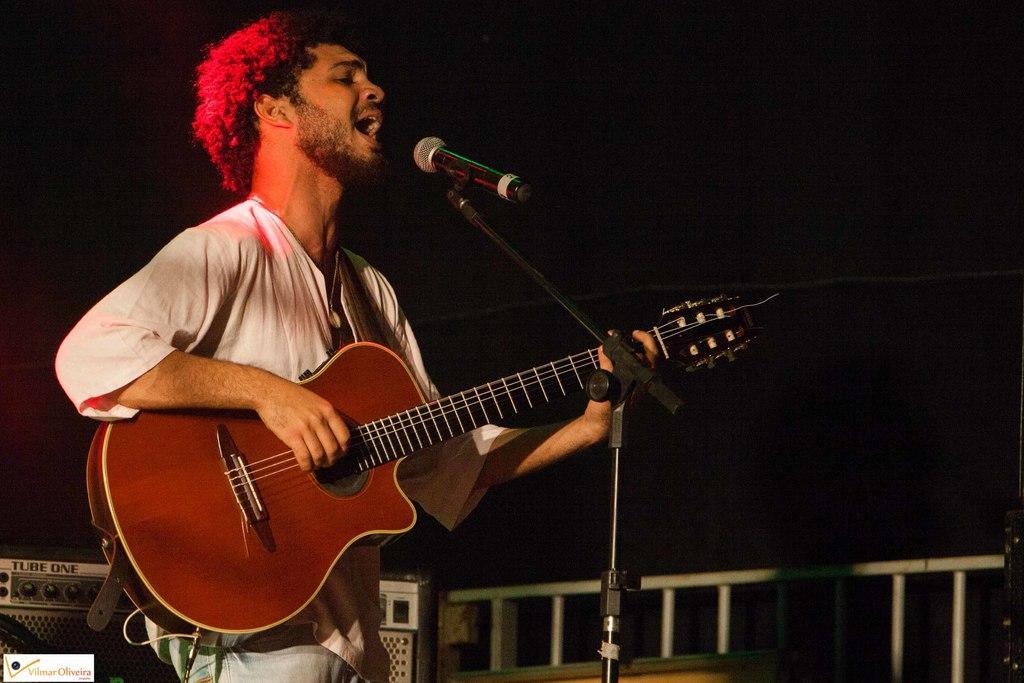In one or two sentences, can you explain what this image depicts? In this image i can see a man holding a guitar in his hand. I can see a microphone in front of him, and in the background i can see a musical set and a railing. 